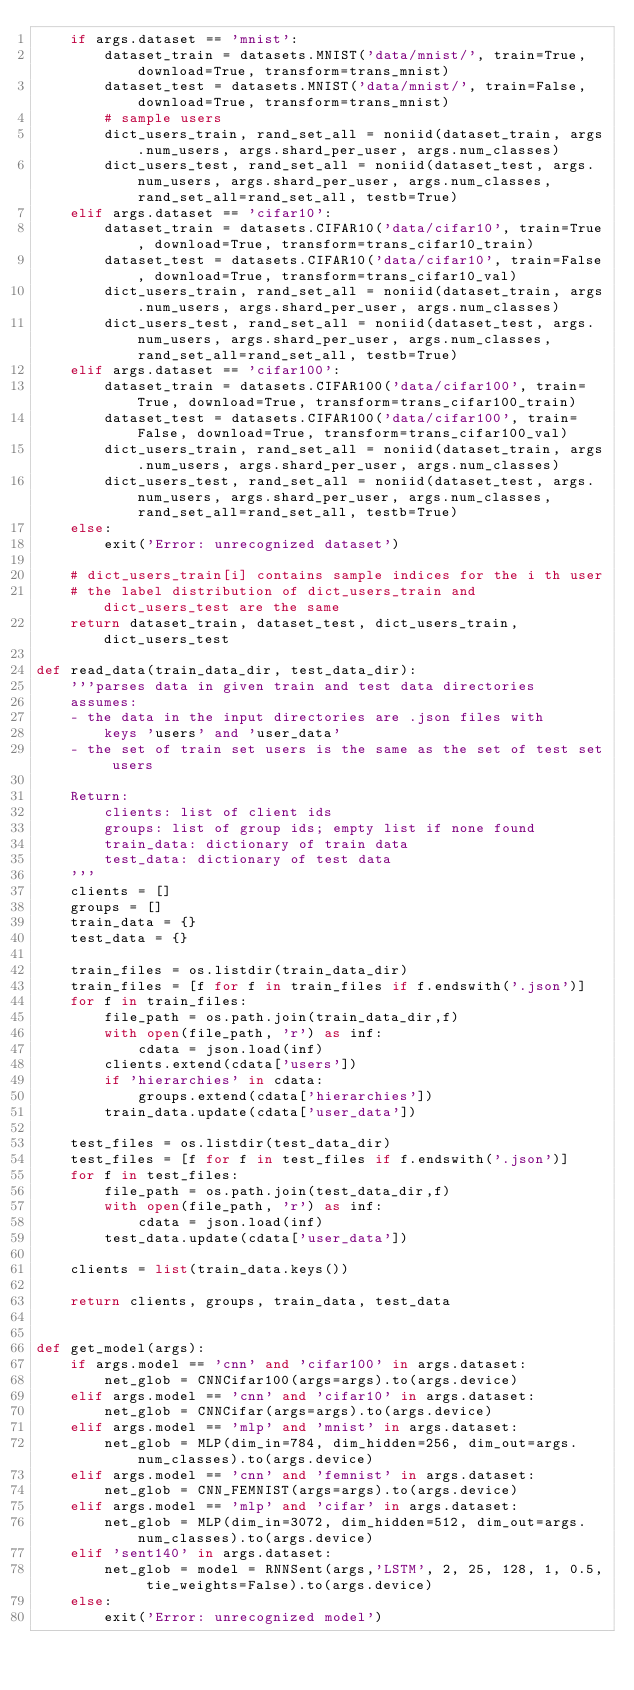<code> <loc_0><loc_0><loc_500><loc_500><_Python_>    if args.dataset == 'mnist':
        dataset_train = datasets.MNIST('data/mnist/', train=True, download=True, transform=trans_mnist)
        dataset_test = datasets.MNIST('data/mnist/', train=False, download=True, transform=trans_mnist)
        # sample users
        dict_users_train, rand_set_all = noniid(dataset_train, args.num_users, args.shard_per_user, args.num_classes)
        dict_users_test, rand_set_all = noniid(dataset_test, args.num_users, args.shard_per_user, args.num_classes, rand_set_all=rand_set_all, testb=True)
    elif args.dataset == 'cifar10':
        dataset_train = datasets.CIFAR10('data/cifar10', train=True, download=True, transform=trans_cifar10_train)
        dataset_test = datasets.CIFAR10('data/cifar10', train=False, download=True, transform=trans_cifar10_val)
        dict_users_train, rand_set_all = noniid(dataset_train, args.num_users, args.shard_per_user, args.num_classes)
        dict_users_test, rand_set_all = noniid(dataset_test, args.num_users, args.shard_per_user, args.num_classes, rand_set_all=rand_set_all, testb=True)
    elif args.dataset == 'cifar100':
        dataset_train = datasets.CIFAR100('data/cifar100', train=True, download=True, transform=trans_cifar100_train)
        dataset_test = datasets.CIFAR100('data/cifar100', train=False, download=True, transform=trans_cifar100_val)
        dict_users_train, rand_set_all = noniid(dataset_train, args.num_users, args.shard_per_user, args.num_classes)
        dict_users_test, rand_set_all = noniid(dataset_test, args.num_users, args.shard_per_user, args.num_classes, rand_set_all=rand_set_all, testb=True)
    else:
        exit('Error: unrecognized dataset')

    # dict_users_train[i] contains sample indices for the i th user
    # the label distribution of dict_users_train and dict_users_test are the same
    return dataset_train, dataset_test, dict_users_train, dict_users_test

def read_data(train_data_dir, test_data_dir):
    '''parses data in given train and test data directories
    assumes:
    - the data in the input directories are .json files with 
        keys 'users' and 'user_data'
    - the set of train set users is the same as the set of test set users
    
    Return:
        clients: list of client ids
        groups: list of group ids; empty list if none found
        train_data: dictionary of train data
        test_data: dictionary of test data
    '''
    clients = []
    groups = []
    train_data = {}
    test_data = {}

    train_files = os.listdir(train_data_dir)
    train_files = [f for f in train_files if f.endswith('.json')]
    for f in train_files:
        file_path = os.path.join(train_data_dir,f)
        with open(file_path, 'r') as inf:
            cdata = json.load(inf)
        clients.extend(cdata['users'])
        if 'hierarchies' in cdata:
            groups.extend(cdata['hierarchies'])
        train_data.update(cdata['user_data'])

    test_files = os.listdir(test_data_dir)
    test_files = [f for f in test_files if f.endswith('.json')]
    for f in test_files:
        file_path = os.path.join(test_data_dir,f)
        with open(file_path, 'r') as inf:
            cdata = json.load(inf)
        test_data.update(cdata['user_data'])

    clients = list(train_data.keys())

    return clients, groups, train_data, test_data


def get_model(args):
    if args.model == 'cnn' and 'cifar100' in args.dataset:
        net_glob = CNNCifar100(args=args).to(args.device)
    elif args.model == 'cnn' and 'cifar10' in args.dataset:
        net_glob = CNNCifar(args=args).to(args.device)
    elif args.model == 'mlp' and 'mnist' in args.dataset:
        net_glob = MLP(dim_in=784, dim_hidden=256, dim_out=args.num_classes).to(args.device)
    elif args.model == 'cnn' and 'femnist' in args.dataset:
        net_glob = CNN_FEMNIST(args=args).to(args.device)
    elif args.model == 'mlp' and 'cifar' in args.dataset:
        net_glob = MLP(dim_in=3072, dim_hidden=512, dim_out=args.num_classes).to(args.device)
    elif 'sent140' in args.dataset:
        net_glob = model = RNNSent(args,'LSTM', 2, 25, 128, 1, 0.5, tie_weights=False).to(args.device)
    else:
        exit('Error: unrecognized model')</code> 